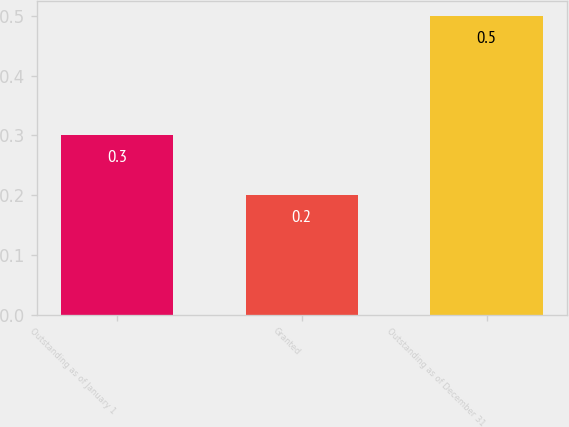Convert chart to OTSL. <chart><loc_0><loc_0><loc_500><loc_500><bar_chart><fcel>Outstanding as of January 1<fcel>Granted<fcel>Outstanding as of December 31<nl><fcel>0.3<fcel>0.2<fcel>0.5<nl></chart> 